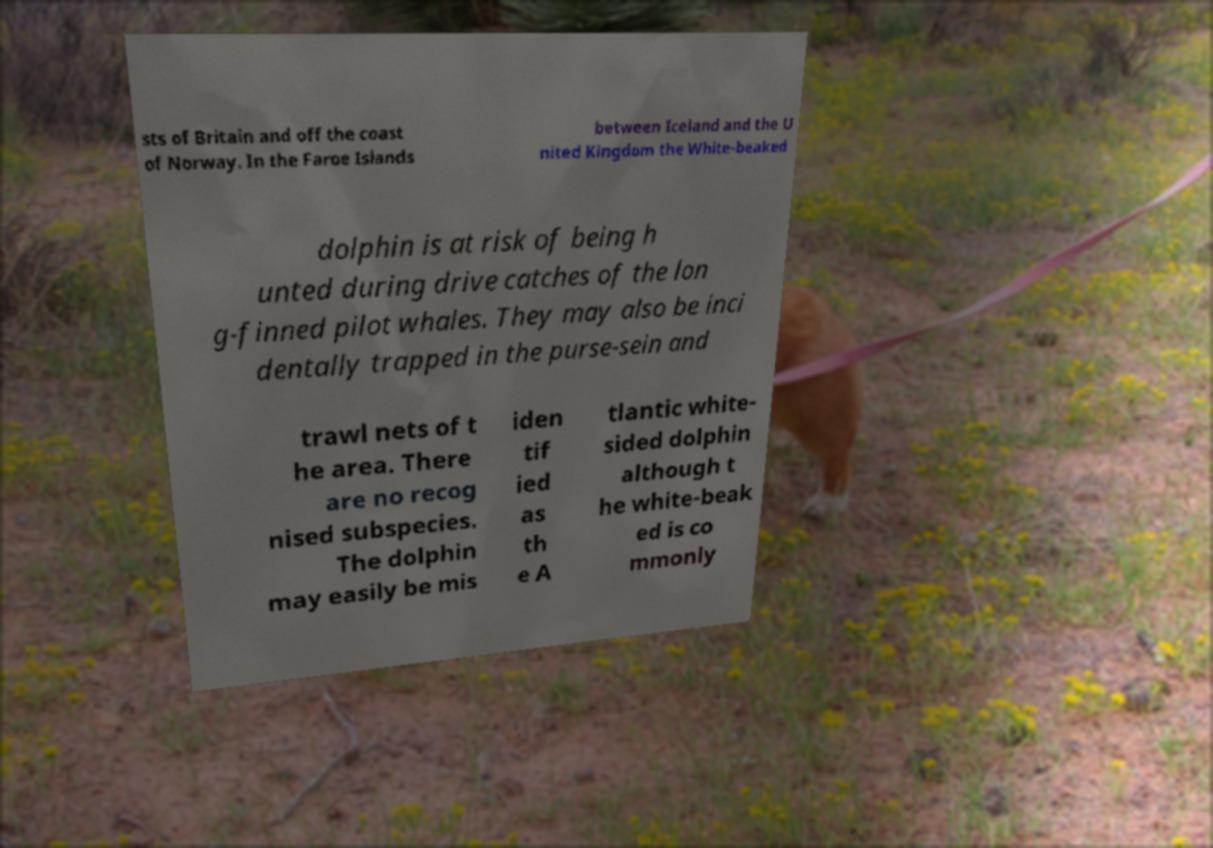Can you accurately transcribe the text from the provided image for me? sts of Britain and off the coast of Norway. In the Faroe Islands between Iceland and the U nited Kingdom the White-beaked dolphin is at risk of being h unted during drive catches of the lon g-finned pilot whales. They may also be inci dentally trapped in the purse-sein and trawl nets of t he area. There are no recog nised subspecies. The dolphin may easily be mis iden tif ied as th e A tlantic white- sided dolphin although t he white-beak ed is co mmonly 